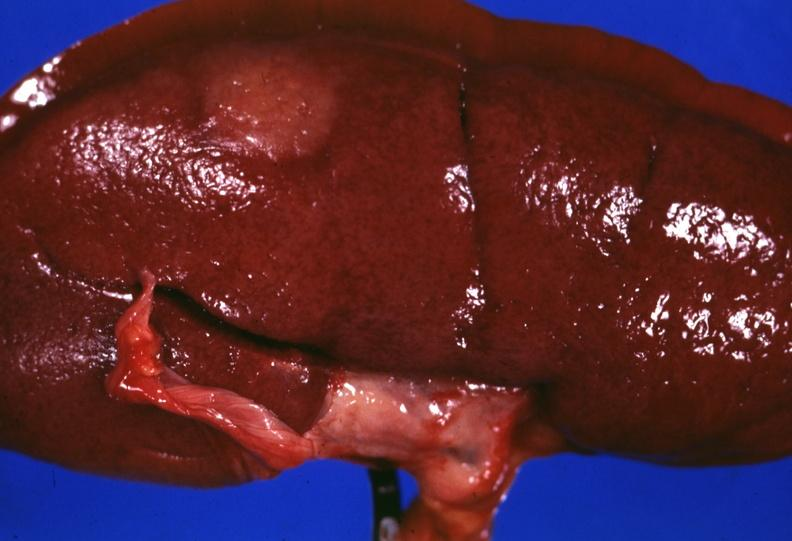what stripped unusual?
Answer the question using a single word or phrase. Surface lesion capsule 